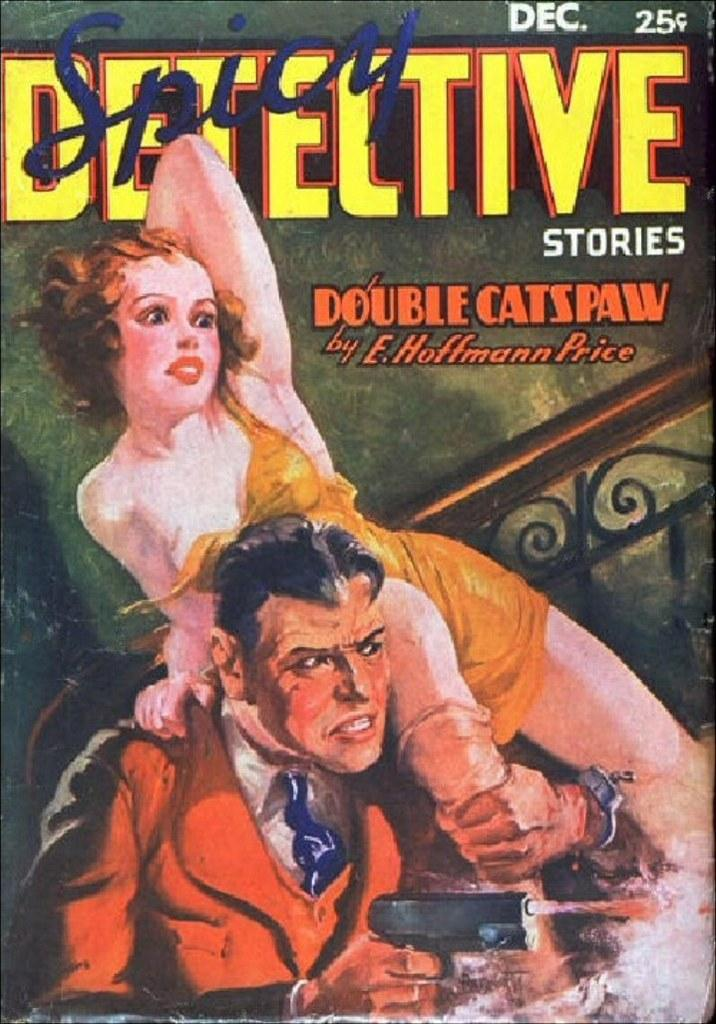<image>
Share a concise interpretation of the image provided. The cover of spicy detective stories by e hoffman price. 